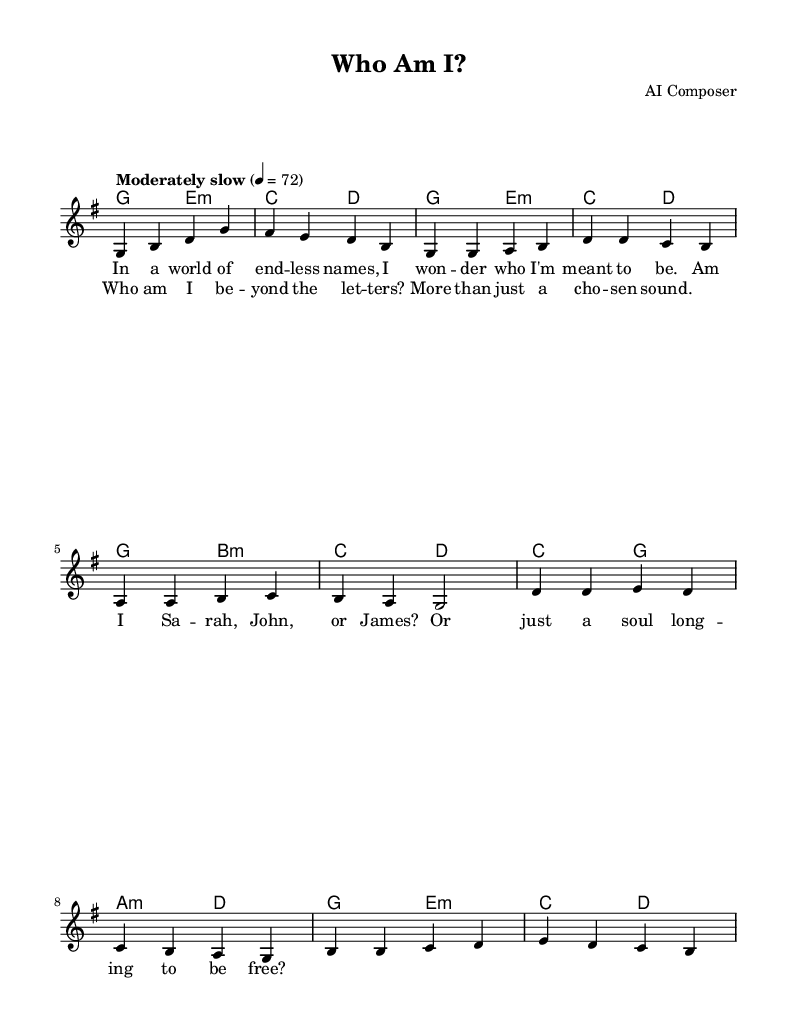What is the key signature of this music? The key signature indicated in the piece is G major, which has one sharp (F#). This is derived from the global settings specified at the start of the sheet music.
Answer: G major What is the time signature of this music? The time signature given in the global settings is 4/4, meaning there are four beats per measure and the quarter note gets one beat. This is explicitly stated in the global section of the code.
Answer: 4/4 What is the tempo marking of this music? The tempo marking listed is "Moderately slow," with a metronome marking of four equals seventy-two. This shows how fast the piece should be played, which is indicated in the global section.
Answer: Moderately slow, 72 How many measures are in the chorus? The chorus consists of four measures, as indicated by the grouping in the melody and the corresponding lyrics for each line. Each line of the chorus comprises one measure, clearly defined in the sheet music.
Answer: Four What are the first two words of the lyrics? The first two words of the lyrics are "In a," which appear in the verse section, specifically under the corresponding melody notes. This can be derived by examining the lyrics aligned with the melody.
Answer: In a Which chord follows the first measure of the anthem? The first measure in the harmony section corresponds to the G major chord, which follows the melody. This is clearly indicated in the chord mode section, where the first harmony written is G for the first measure.
Answer: G What is the main theme explored in the lyrics? The main theme in the lyrics revolves around identity and self-discovery, highlighted by the questioning phrases and reflections on names, indicating a search for personal meaning. This is observed through the overall message conveyed in the lyrics.
Answer: Identity and self-discovery 